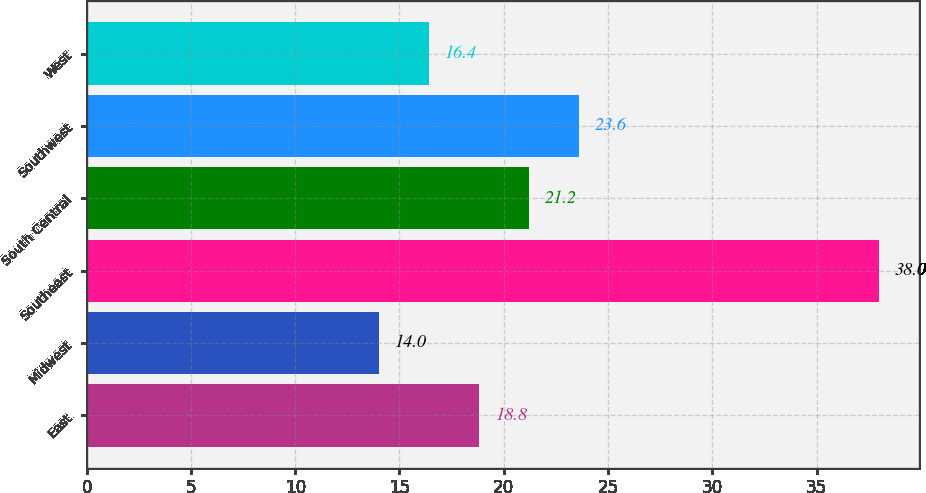<chart> <loc_0><loc_0><loc_500><loc_500><bar_chart><fcel>East<fcel>Midwest<fcel>Southeast<fcel>South Central<fcel>Southwest<fcel>West<nl><fcel>18.8<fcel>14<fcel>38<fcel>21.2<fcel>23.6<fcel>16.4<nl></chart> 